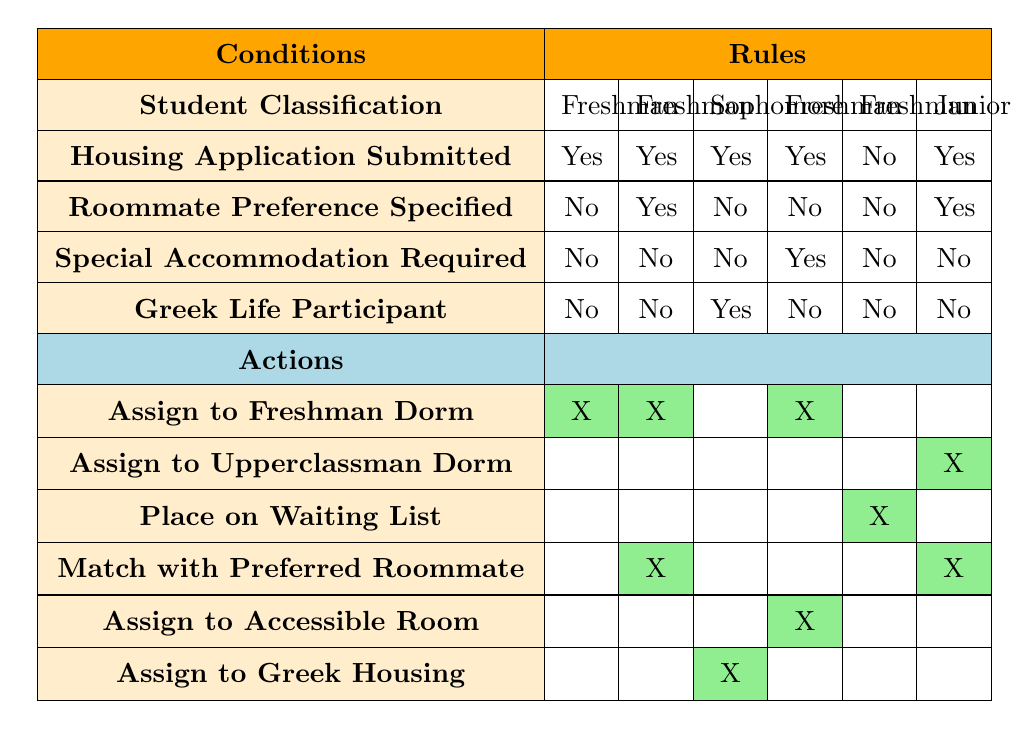What dorm will a freshman who submitted their application but did not specify a roommate preference receive? According to the table, for a freshman who has submitted their application and has not specified a roommate preference, they will be assigned to a Freshman Dorm.
Answer: Freshman Dorm Is a sophomore who is a Greek Life participant eligible for Greek Housing? Yes, the table indicates that if a sophomore is a Greek Life participant and applies for housing, they will be assigned to Greek Housing.
Answer: Yes How many students will be placed on the waiting list if they are freshmen and did not submit a housing application? From the table, a freshman who did not submit a housing application will be placed on the waiting list. There is only one relevant rule that confirms this.
Answer: 1 If a freshman requires special accommodations and has submitted their application, what will their assignment be? The table shows that a freshman who requires special accommodations and has submitted their application will be assigned to an accessible room, in addition to being assigned to a Freshman Dorm.
Answer: Accessible Room What are the dormitory assignment outcomes for students who are juniors and have specified a roommate preference? According to the table, if a junior has submitted their application and specified a roommate preference, they will be assigned to an Upperclassman Dorm and matched with their preferred roommate.
Answer: Upperclassman Dorm, Match with Preferred Roommate 